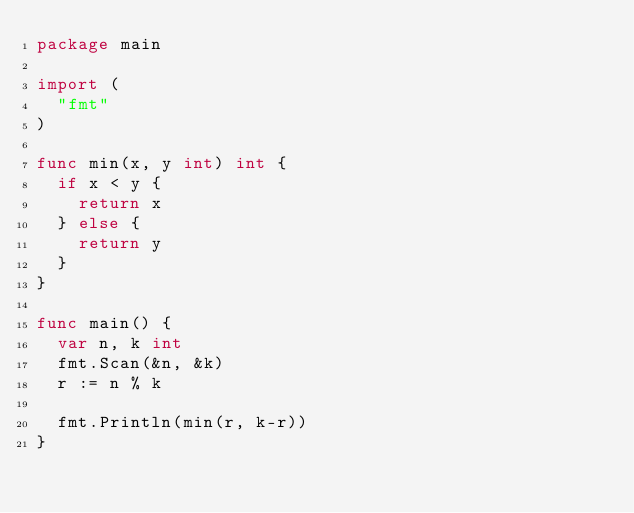<code> <loc_0><loc_0><loc_500><loc_500><_Go_>package main

import (
	"fmt"
)

func min(x, y int) int {
	if x < y {
		return x
	} else {
		return y
	}
}

func main() {
	var n, k int
	fmt.Scan(&n, &k)
	r := n % k

	fmt.Println(min(r, k-r))
}
</code> 